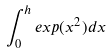<formula> <loc_0><loc_0><loc_500><loc_500>\int _ { 0 } ^ { h } e x p ( x ^ { 2 } ) d x</formula> 